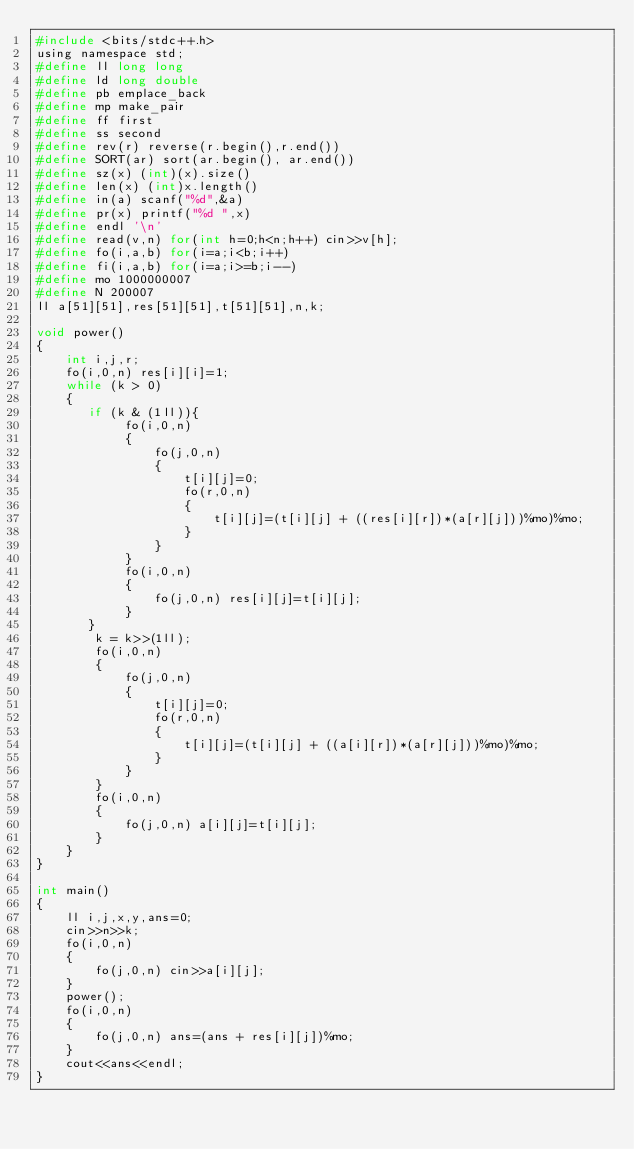<code> <loc_0><loc_0><loc_500><loc_500><_C_>#include <bits/stdc++.h>
using namespace std;
#define ll long long
#define ld long double
#define pb emplace_back
#define mp make_pair
#define ff first
#define ss second
#define rev(r) reverse(r.begin(),r.end())
#define SORT(ar) sort(ar.begin(), ar.end())
#define sz(x) (int)(x).size()
#define len(x) (int)x.length()
#define in(a) scanf("%d",&a)
#define pr(x) printf("%d ",x)
#define endl '\n'
#define read(v,n) for(int h=0;h<n;h++) cin>>v[h];
#define fo(i,a,b) for(i=a;i<b;i++)
#define fi(i,a,b) for(i=a;i>=b;i--)
#define mo 1000000007
#define N 200007
ll a[51][51],res[51][51],t[51][51],n,k;

void power()
{
    int i,j,r;
    fo(i,0,n) res[i][i]=1;
    while (k > 0)
    {
       if (k & (1ll)){
            fo(i,0,n)
            {
                fo(j,0,n)
                {
                    t[i][j]=0;
                    fo(r,0,n)
                    {
                        t[i][j]=(t[i][j] + ((res[i][r])*(a[r][j]))%mo)%mo;
                    }
                }
            }
            fo(i,0,n)
            {
                fo(j,0,n) res[i][j]=t[i][j];
            }
       }
        k = k>>(1ll);
        fo(i,0,n)
        {
            fo(j,0,n)
            {
                t[i][j]=0;
                fo(r,0,n)
                {
                    t[i][j]=(t[i][j] + ((a[i][r])*(a[r][j]))%mo)%mo;
                }
            }
        }
        fo(i,0,n)
        {
            fo(j,0,n) a[i][j]=t[i][j];
        }
    }
}

int main()
{
    ll i,j,x,y,ans=0;
    cin>>n>>k;
    fo(i,0,n)
    {
        fo(j,0,n) cin>>a[i][j];
    }
    power();
    fo(i,0,n)
    {
        fo(j,0,n) ans=(ans + res[i][j])%mo;
    }
    cout<<ans<<endl;
}
</code> 